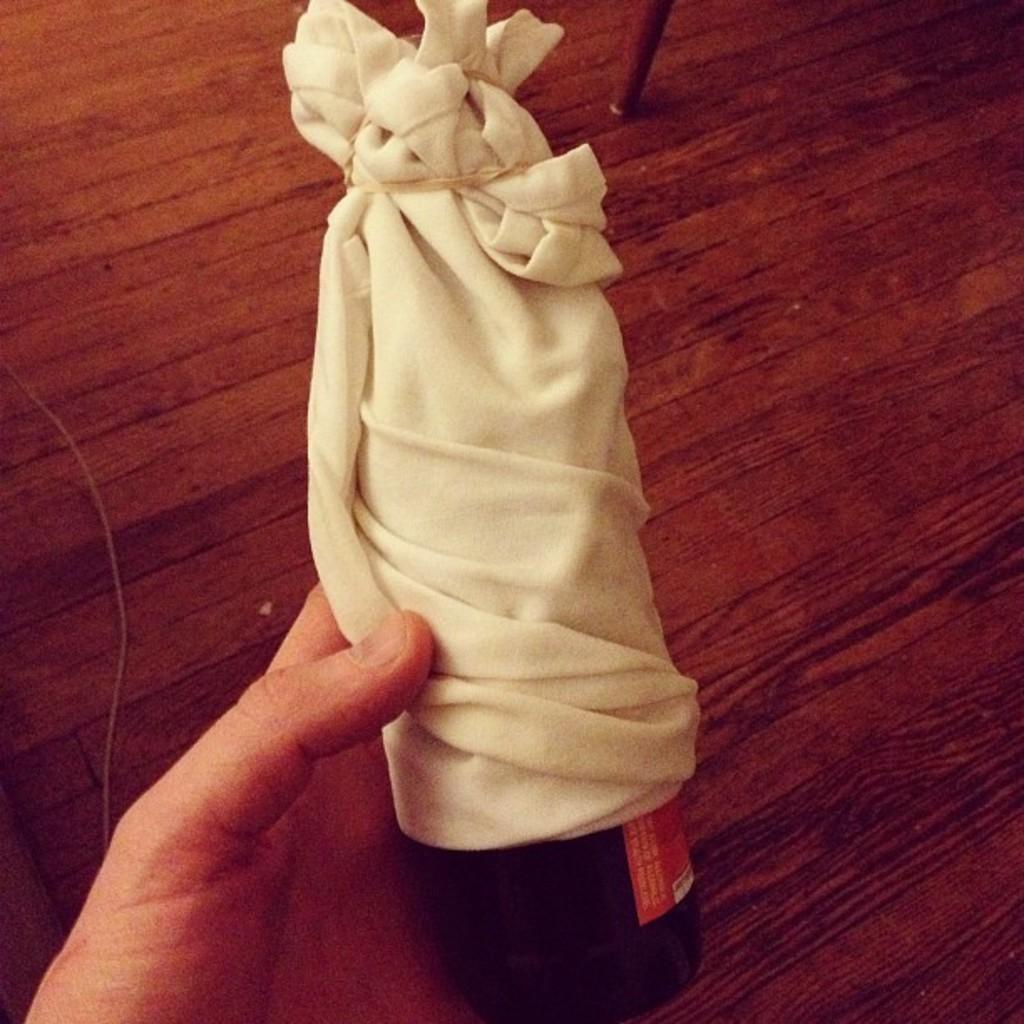Can you describe this image briefly? In this picture we can see a person's hand who is holding a wine bottle. This bottle is covered by white cloth. On the top we can see chair. Here we can see wooden floor. On the left there is a white color wire. 